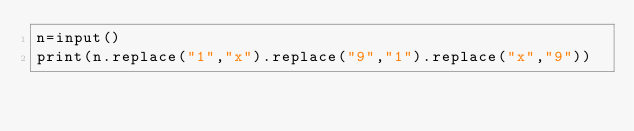Convert code to text. <code><loc_0><loc_0><loc_500><loc_500><_Python_>n=input()
print(n.replace("1","x").replace("9","1").replace("x","9"))</code> 